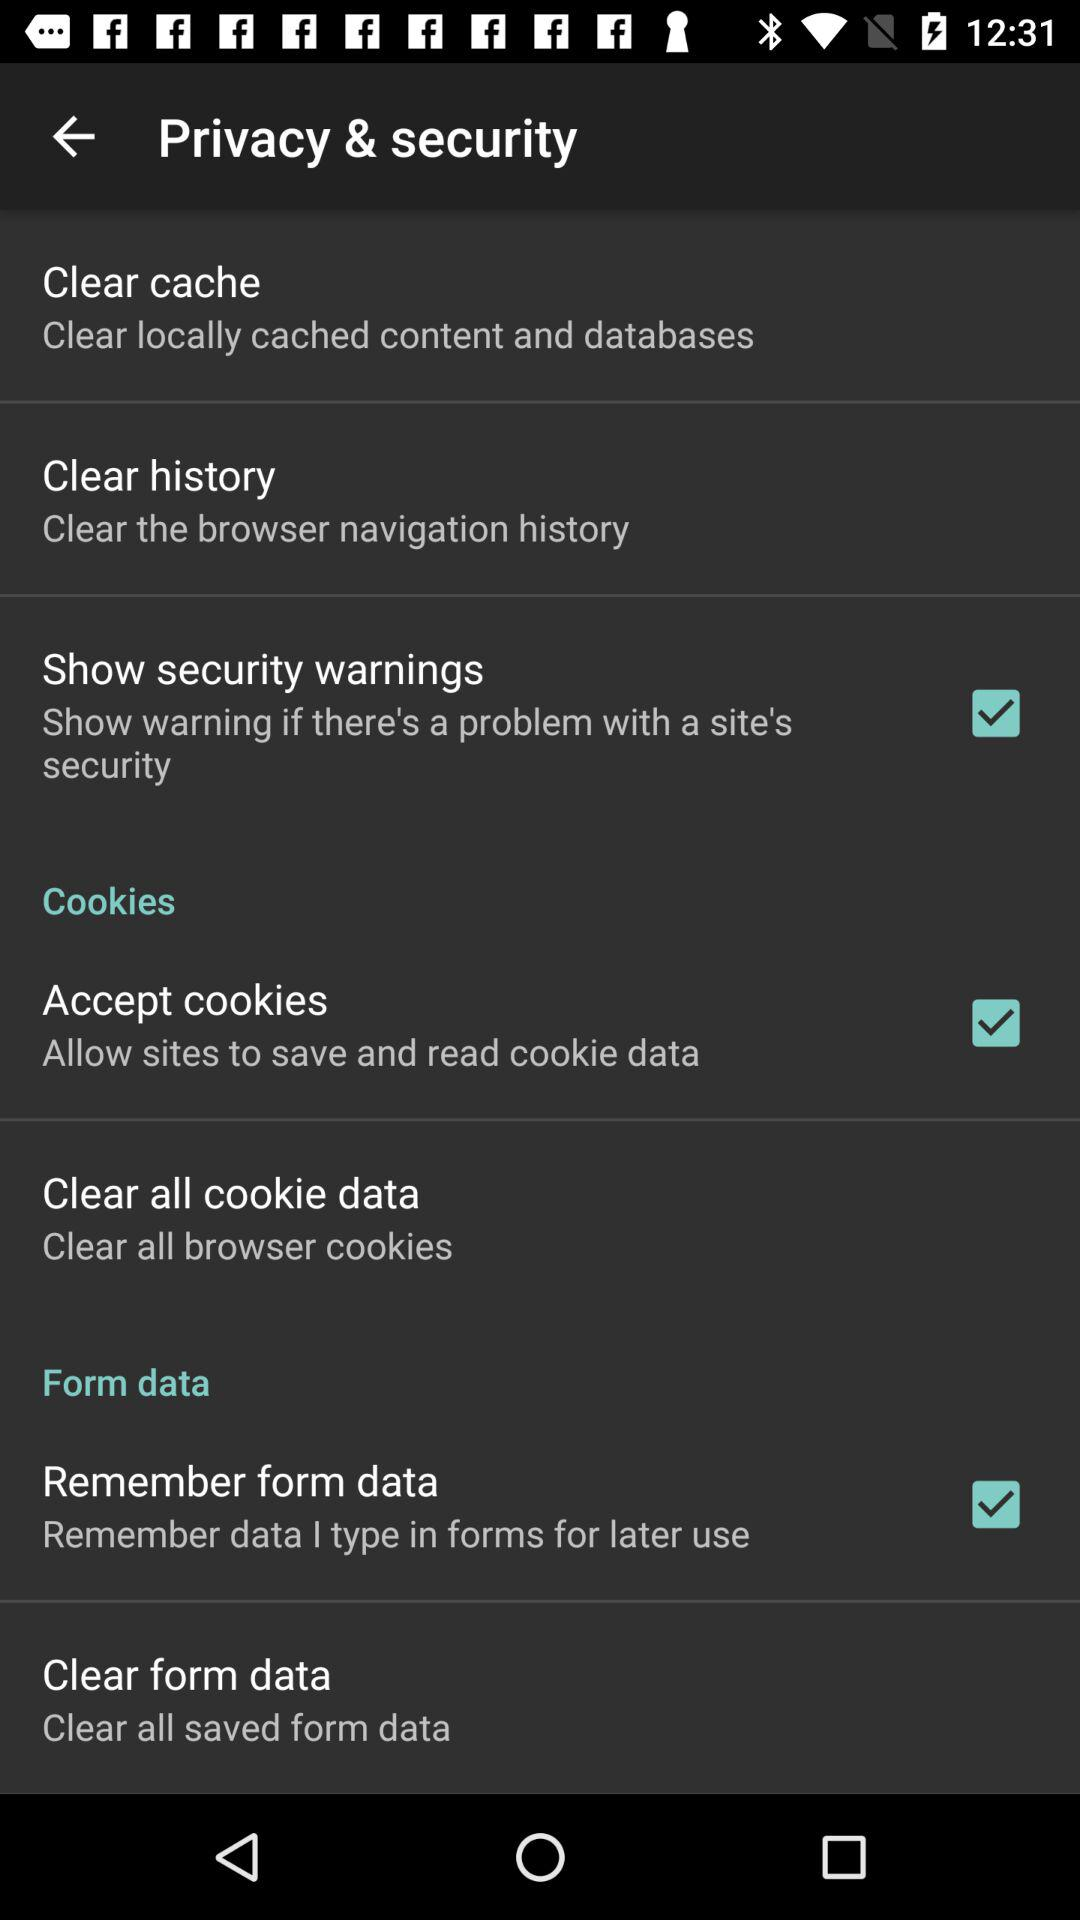Has the data been cleared?
When the provided information is insufficient, respond with <no answer>. <no answer> 